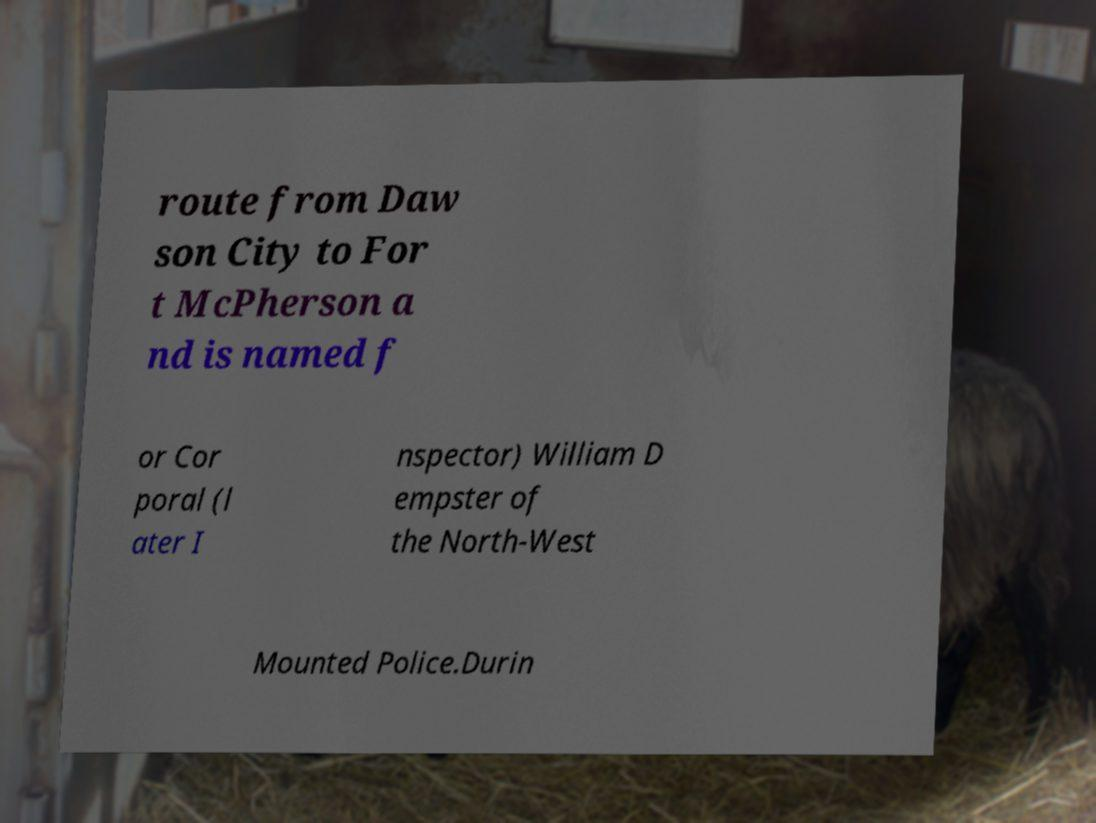Can you read and provide the text displayed in the image?This photo seems to have some interesting text. Can you extract and type it out for me? route from Daw son City to For t McPherson a nd is named f or Cor poral (l ater I nspector) William D empster of the North-West Mounted Police.Durin 